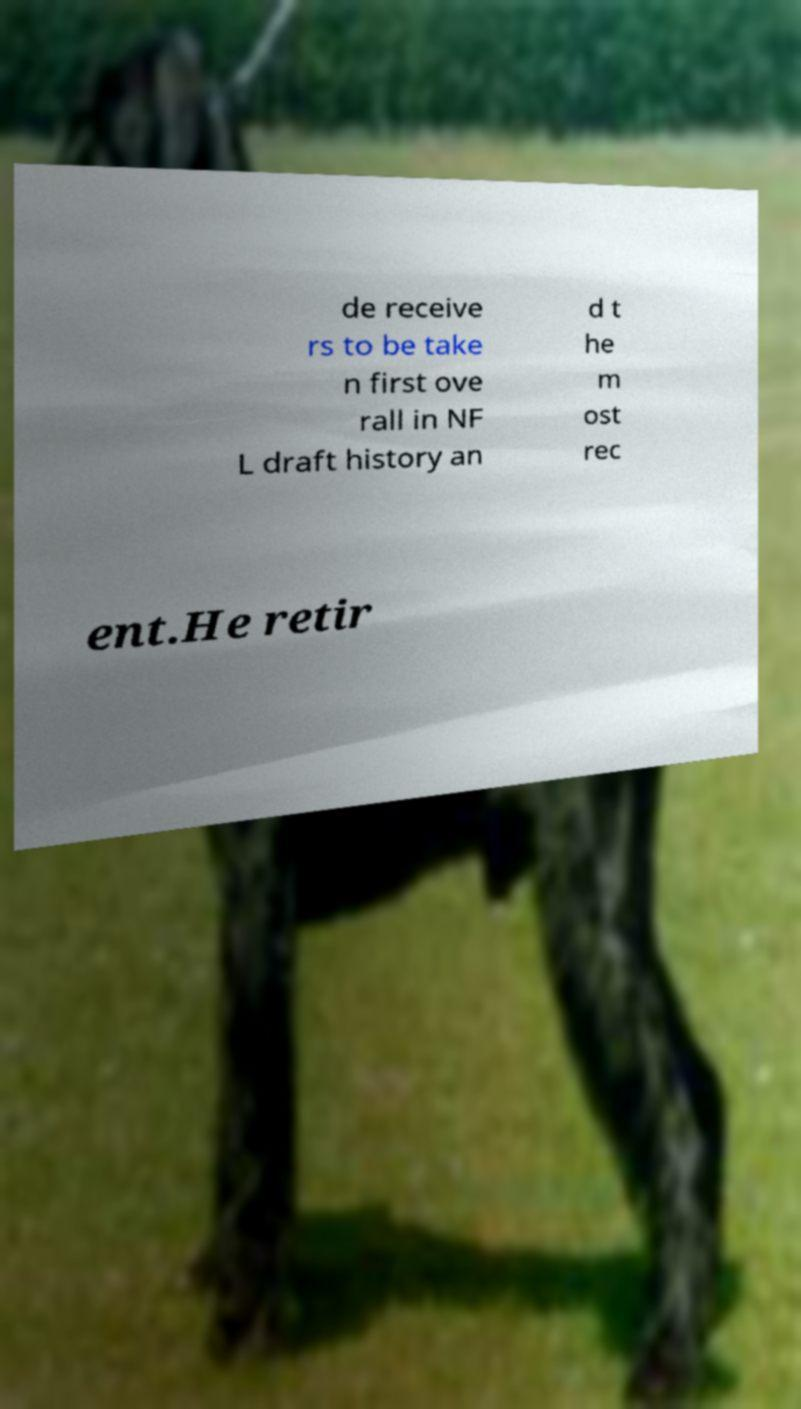I need the written content from this picture converted into text. Can you do that? de receive rs to be take n first ove rall in NF L draft history an d t he m ost rec ent.He retir 